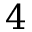Convert formula to latex. <formula><loc_0><loc_0><loc_500><loc_500>4</formula> 